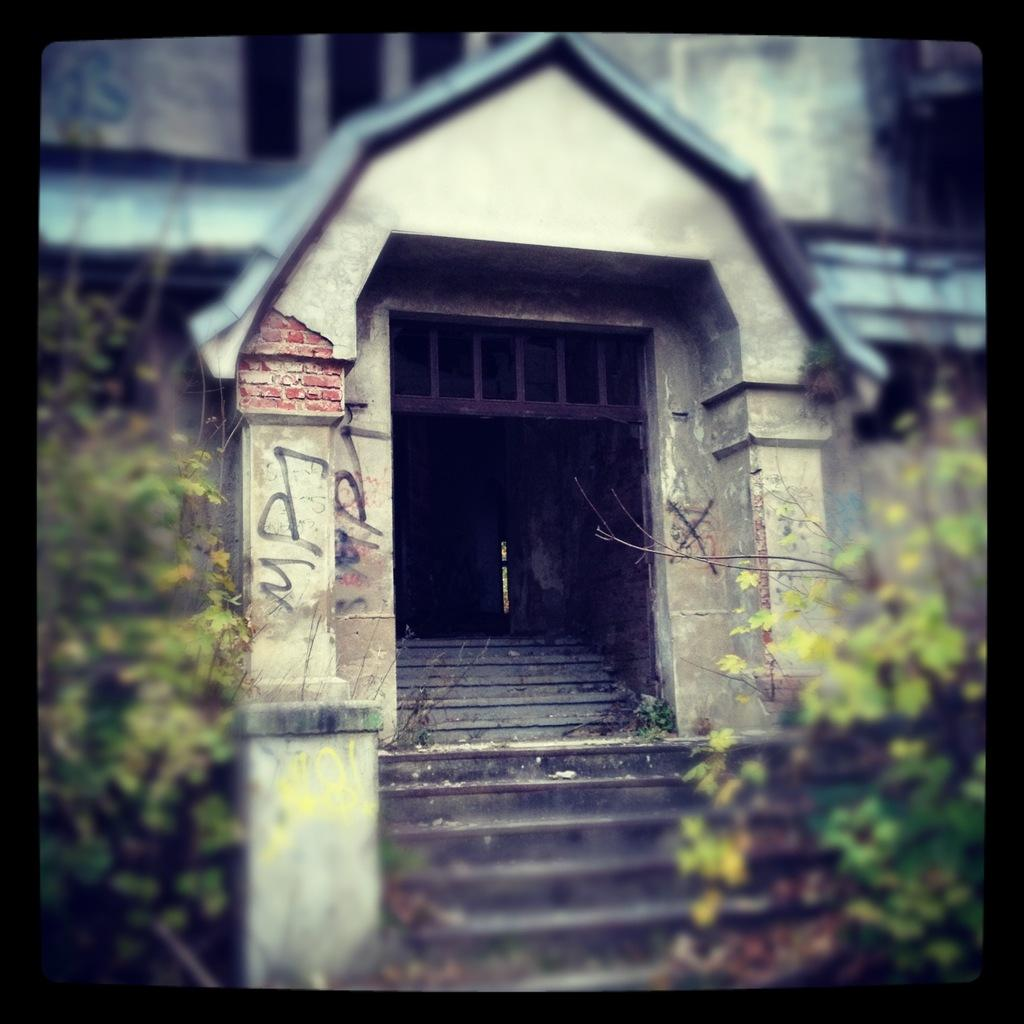What type of living organisms can be seen in the image? Plants can be seen in the image. What architectural feature is present in the image? There are stairs in the image. What is located on the building in the image? There are objects on the building in the image. What type of thread is being used to create the peace symbol in the image? There is no peace symbol or thread present in the image. 